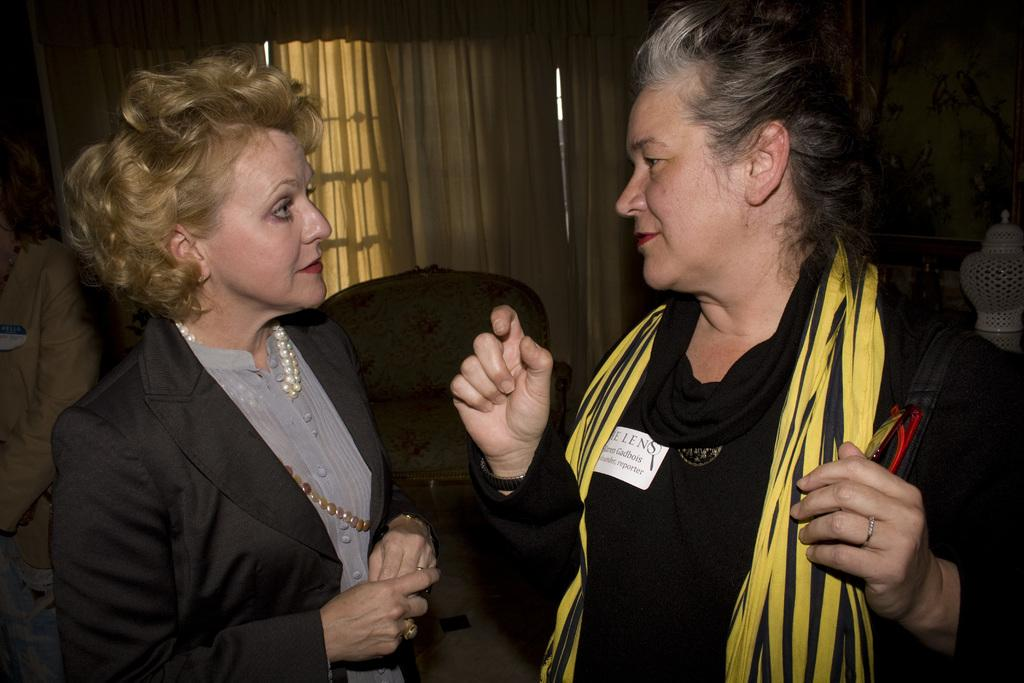Who is present in the image? There are women in the image. What are the women doing in the image? The women are standing on the floor. What can be seen in the background of the image? There are chairs, a person, a window, and a curtain associated with the window in the background of the image. What type of record can be seen on the floor in the image? There is no record present on the floor in the image. 